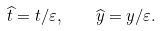Convert formula to latex. <formula><loc_0><loc_0><loc_500><loc_500>\widehat { t } = t / \varepsilon , \text { \ \ } \widehat { y } = y / \varepsilon .</formula> 